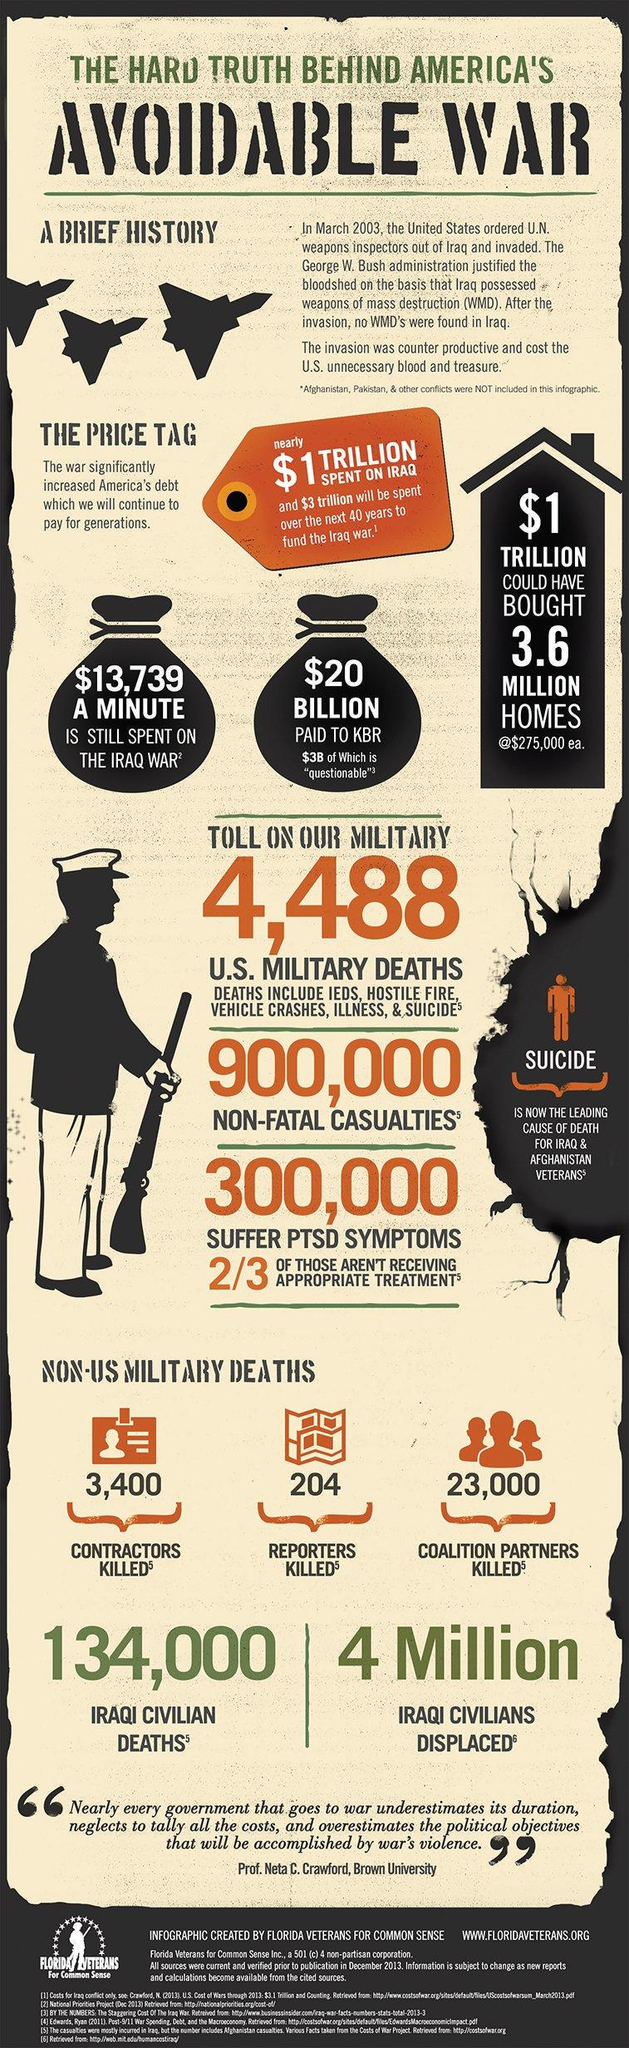Mention a couple of crucial points in this snapshot. A total of 3,604 contractors and reporters lost their lives in the war in Iraq. The website of the organization named 'FloridaVeterans.org' is as follows: [www.floridaveterans.org](http://www.floridaveterans.org). Florida Veterans for Common Sense is mentioned. 